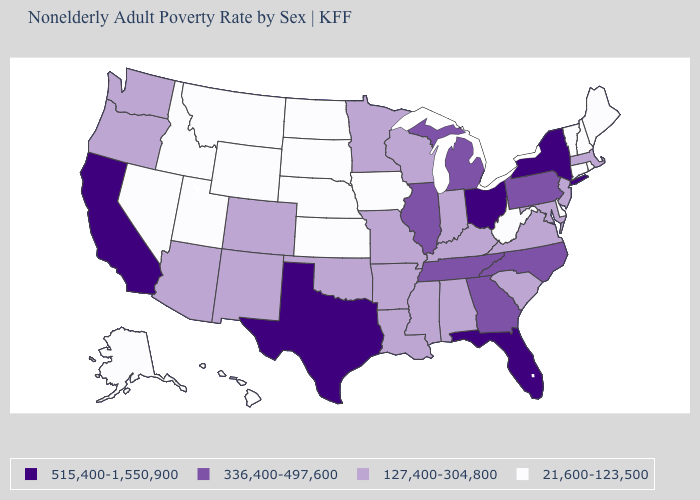What is the value of Mississippi?
Keep it brief. 127,400-304,800. What is the value of Massachusetts?
Keep it brief. 127,400-304,800. What is the value of Maryland?
Write a very short answer. 127,400-304,800. How many symbols are there in the legend?
Keep it brief. 4. Does West Virginia have the lowest value in the South?
Quick response, please. Yes. Name the states that have a value in the range 515,400-1,550,900?
Answer briefly. California, Florida, New York, Ohio, Texas. Among the states that border North Carolina , which have the highest value?
Quick response, please. Georgia, Tennessee. Which states hav the highest value in the MidWest?
Write a very short answer. Ohio. Does South Carolina have the highest value in the South?
Answer briefly. No. Name the states that have a value in the range 515,400-1,550,900?
Concise answer only. California, Florida, New York, Ohio, Texas. Is the legend a continuous bar?
Be succinct. No. Which states have the lowest value in the USA?
Answer briefly. Alaska, Connecticut, Delaware, Hawaii, Idaho, Iowa, Kansas, Maine, Montana, Nebraska, Nevada, New Hampshire, North Dakota, Rhode Island, South Dakota, Utah, Vermont, West Virginia, Wyoming. Which states have the lowest value in the USA?
Write a very short answer. Alaska, Connecticut, Delaware, Hawaii, Idaho, Iowa, Kansas, Maine, Montana, Nebraska, Nevada, New Hampshire, North Dakota, Rhode Island, South Dakota, Utah, Vermont, West Virginia, Wyoming. What is the value of Maine?
Quick response, please. 21,600-123,500. 